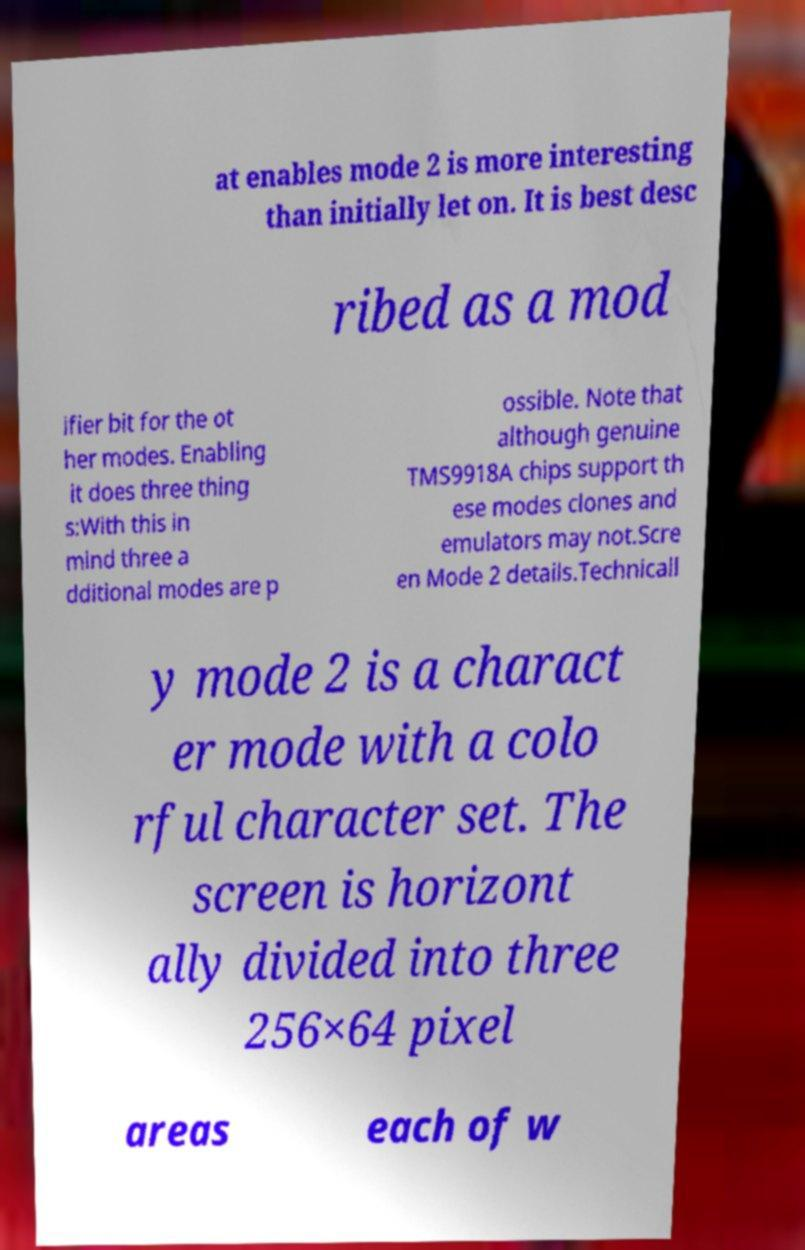What messages or text are displayed in this image? I need them in a readable, typed format. at enables mode 2 is more interesting than initially let on. It is best desc ribed as a mod ifier bit for the ot her modes. Enabling it does three thing s:With this in mind three a dditional modes are p ossible. Note that although genuine TMS9918A chips support th ese modes clones and emulators may not.Scre en Mode 2 details.Technicall y mode 2 is a charact er mode with a colo rful character set. The screen is horizont ally divided into three 256×64 pixel areas each of w 